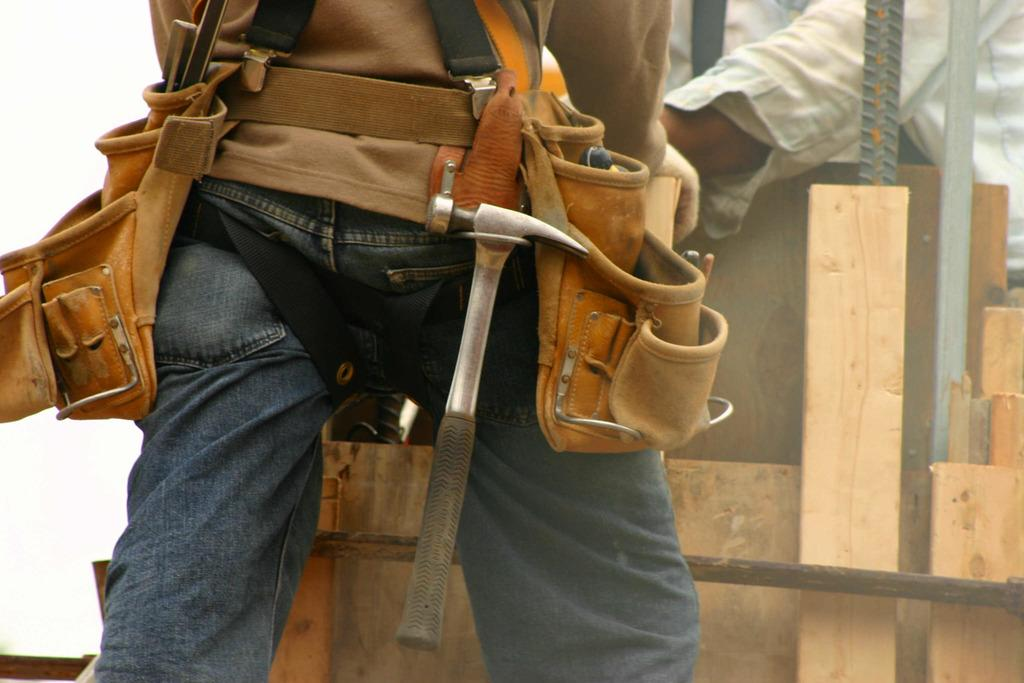How many people are in the image? There are two persons in the image. What objects can be seen in the image besides the people? Bags, metal rods, wooden sticks, and a hammer are visible in the image. What type of structure is in the background of the image? There is a wall in the image. Can you describe the lighting conditions in the image? The image was likely taken during the day, as there is sufficient natural light. What color ink is being used by the person getting a haircut in the image? There is no person getting a haircut in the image, nor is there any ink present. 